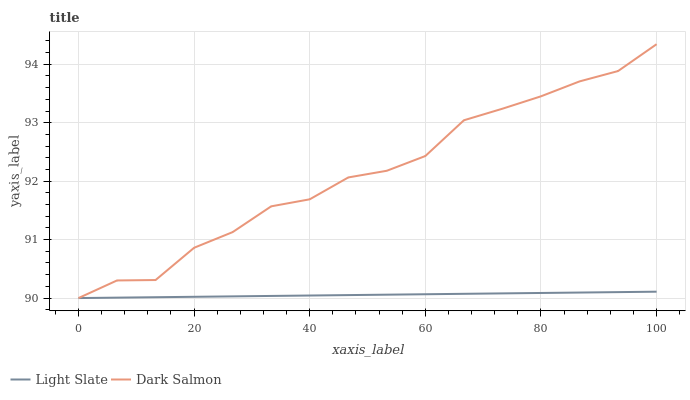Does Light Slate have the minimum area under the curve?
Answer yes or no. Yes. Does Dark Salmon have the maximum area under the curve?
Answer yes or no. Yes. Does Dark Salmon have the minimum area under the curve?
Answer yes or no. No. Is Light Slate the smoothest?
Answer yes or no. Yes. Is Dark Salmon the roughest?
Answer yes or no. Yes. Is Dark Salmon the smoothest?
Answer yes or no. No. 